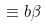Convert formula to latex. <formula><loc_0><loc_0><loc_500><loc_500>\equiv b \beta</formula> 